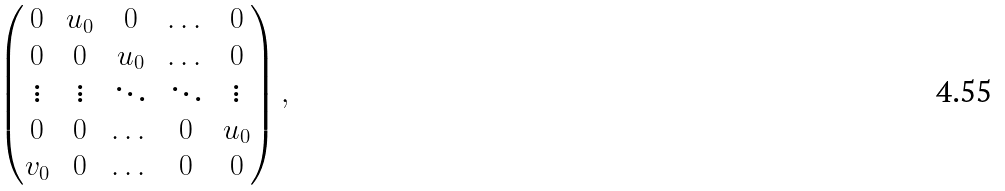<formula> <loc_0><loc_0><loc_500><loc_500>\begin{pmatrix} 0 & u _ { 0 } & 0 & \dots & 0 \\ 0 & 0 & u _ { 0 } & \dots & 0 \\ \vdots & \vdots & \ddots & \ddots & \vdots \\ 0 & 0 & \dots & 0 & u _ { 0 } \\ v _ { 0 } & 0 & \dots & 0 & 0 \end{pmatrix} ,</formula> 